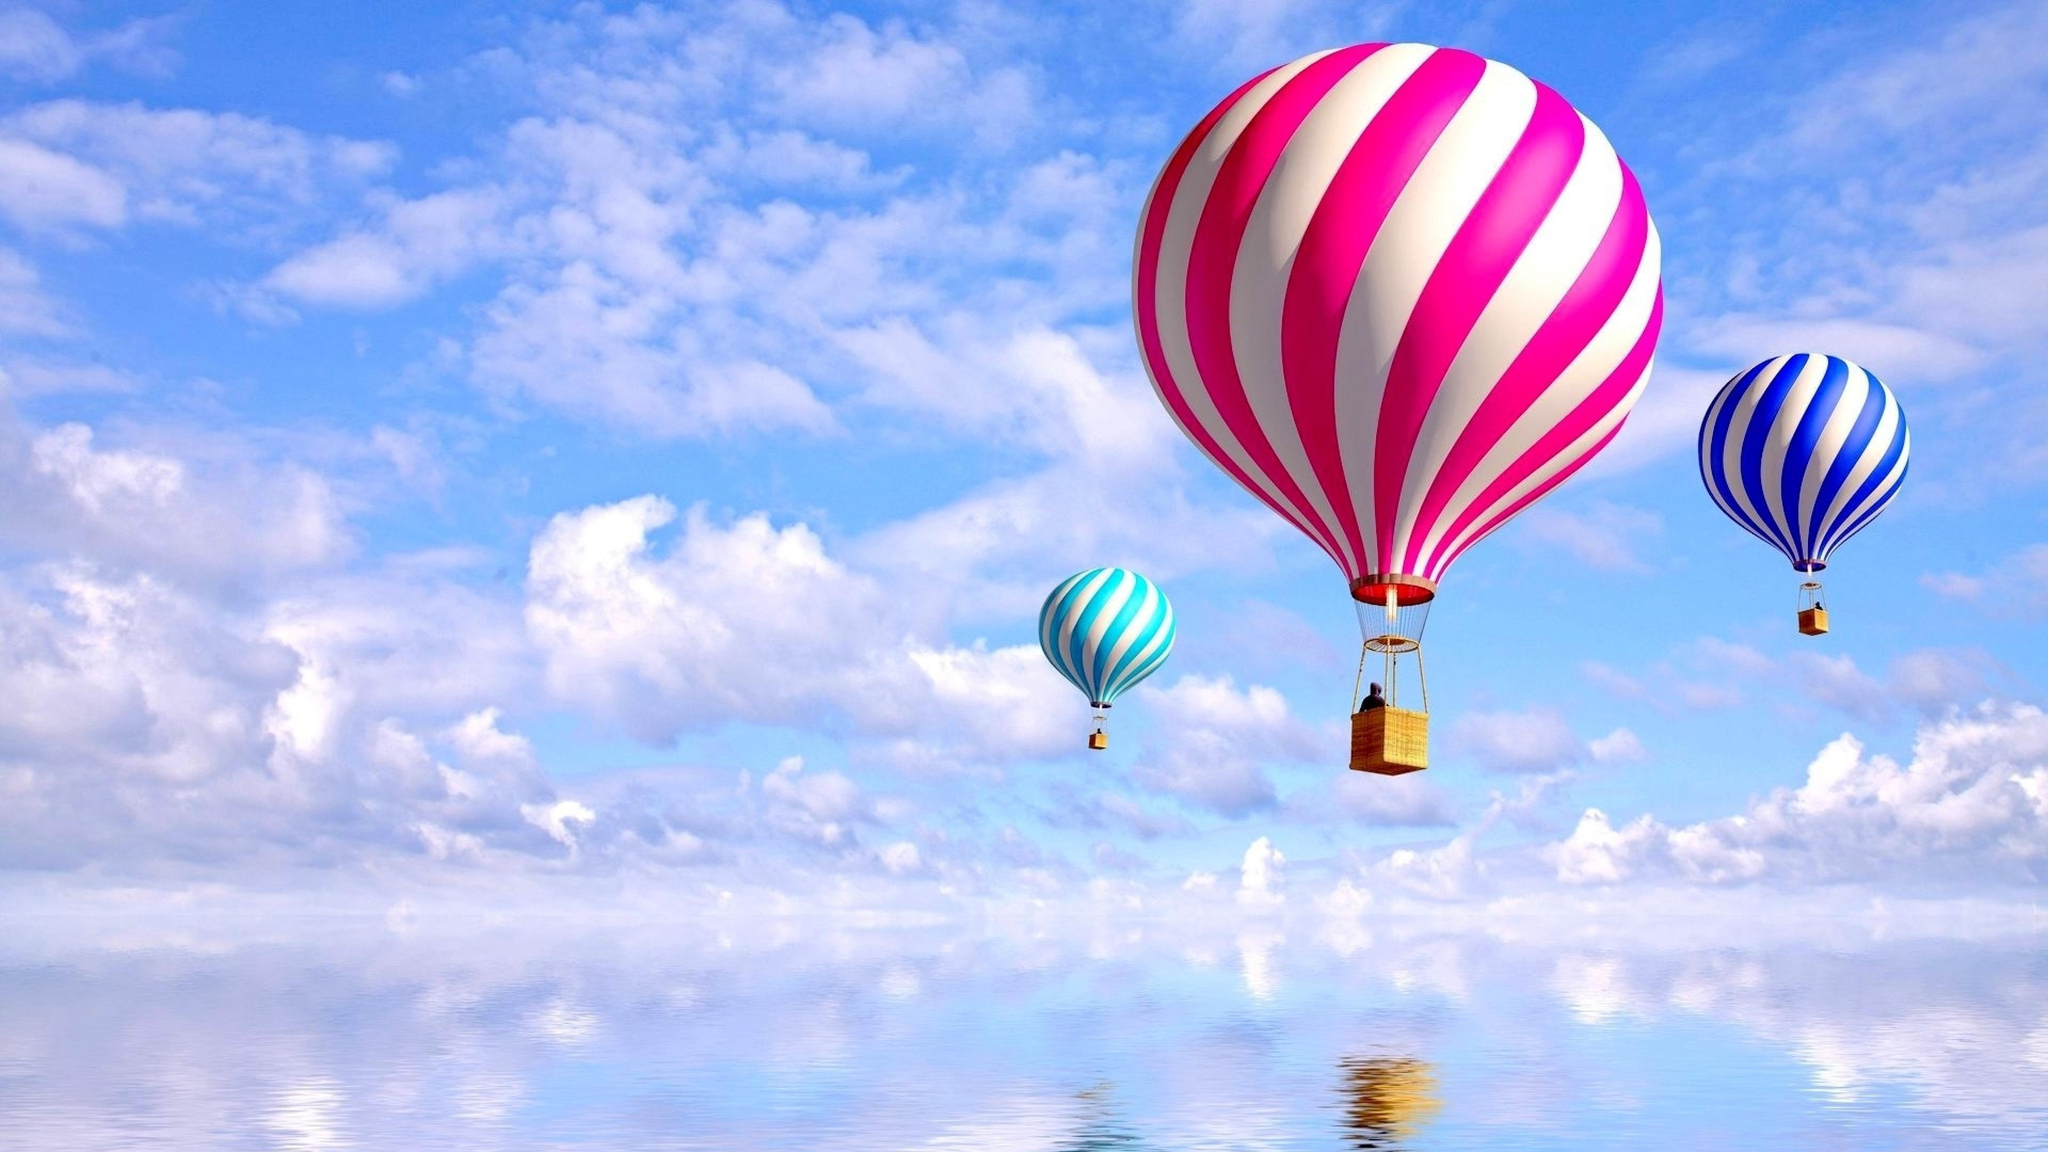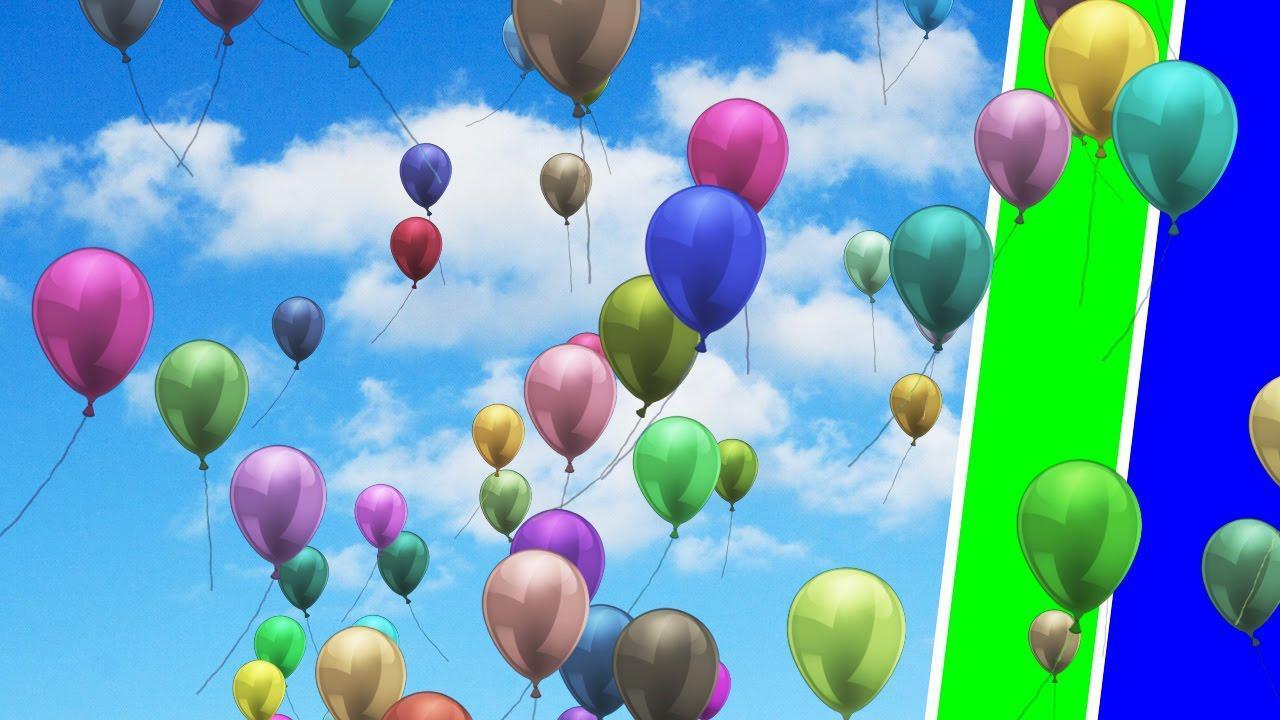The first image is the image on the left, the second image is the image on the right. For the images displayed, is the sentence "There are three hot air balloons." factually correct? Answer yes or no. Yes. The first image is the image on the left, the second image is the image on the right. Evaluate the accuracy of this statement regarding the images: "There are balloons tied together.". Is it true? Answer yes or no. No. 